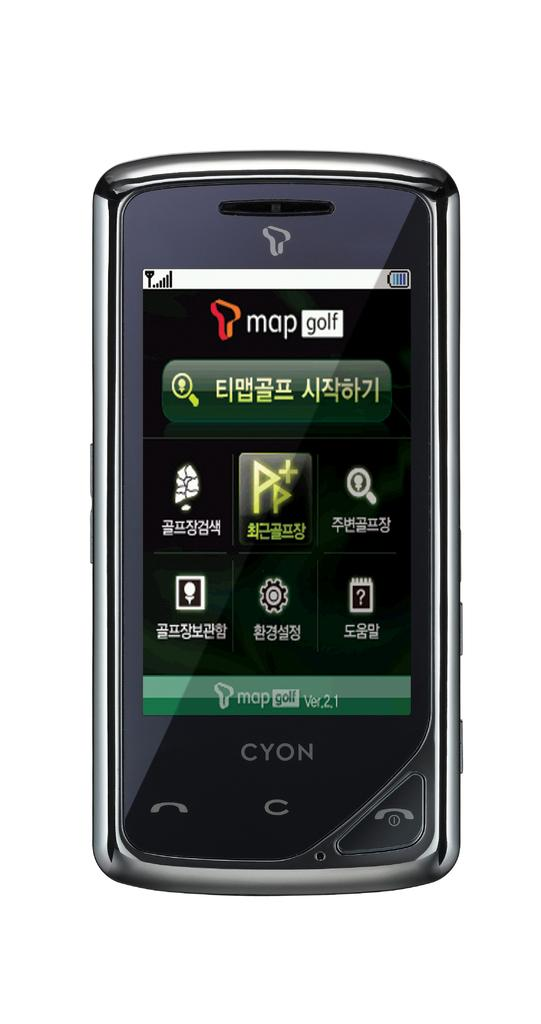<image>
Create a compact narrative representing the image presented. A cellphone map golf app is open and being used. 